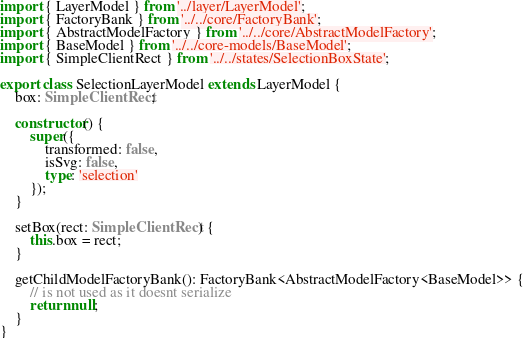Convert code to text. <code><loc_0><loc_0><loc_500><loc_500><_TypeScript_>import { LayerModel } from '../layer/LayerModel';
import { FactoryBank } from '../../core/FactoryBank';
import { AbstractModelFactory } from '../../core/AbstractModelFactory';
import { BaseModel } from '../../core-models/BaseModel';
import { SimpleClientRect } from '../../states/SelectionBoxState';

export class SelectionLayerModel extends LayerModel {
	box: SimpleClientRect;

	constructor() {
		super({
			transformed: false,
			isSvg: false,
			type: 'selection'
		});
	}

	setBox(rect: SimpleClientRect) {
		this.box = rect;
	}

	getChildModelFactoryBank(): FactoryBank<AbstractModelFactory<BaseModel>> {
		// is not used as it doesnt serialize
		return null;
	}
}
</code> 